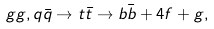Convert formula to latex. <formula><loc_0><loc_0><loc_500><loc_500>g g , q { \bar { q } } \rightarrow t { \bar { t } } \rightarrow b { \bar { b } } + 4 f + g ,</formula> 